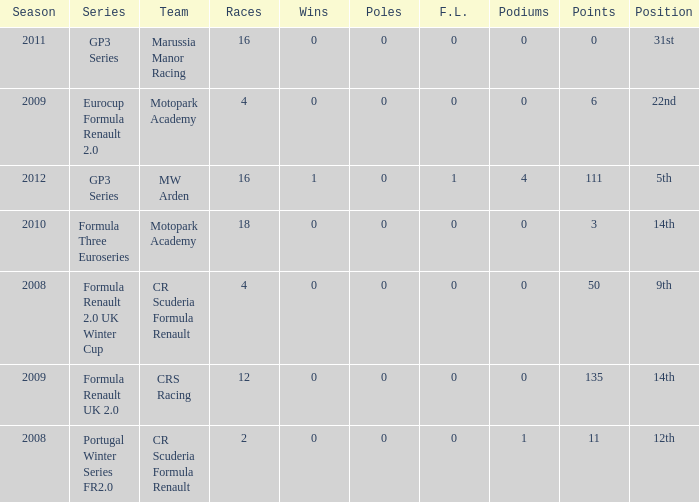How many points does Marussia Manor Racing have? 1.0. 